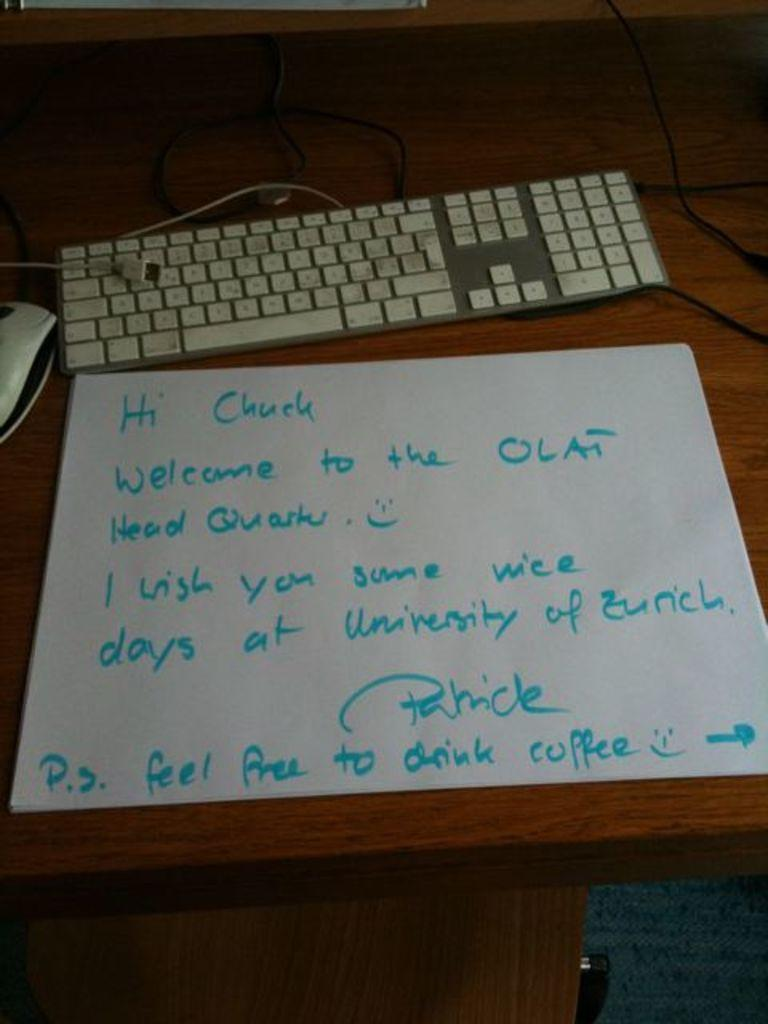<image>
Give a short and clear explanation of the subsequent image. A note next to a keyboard is addressed to Chuck. 